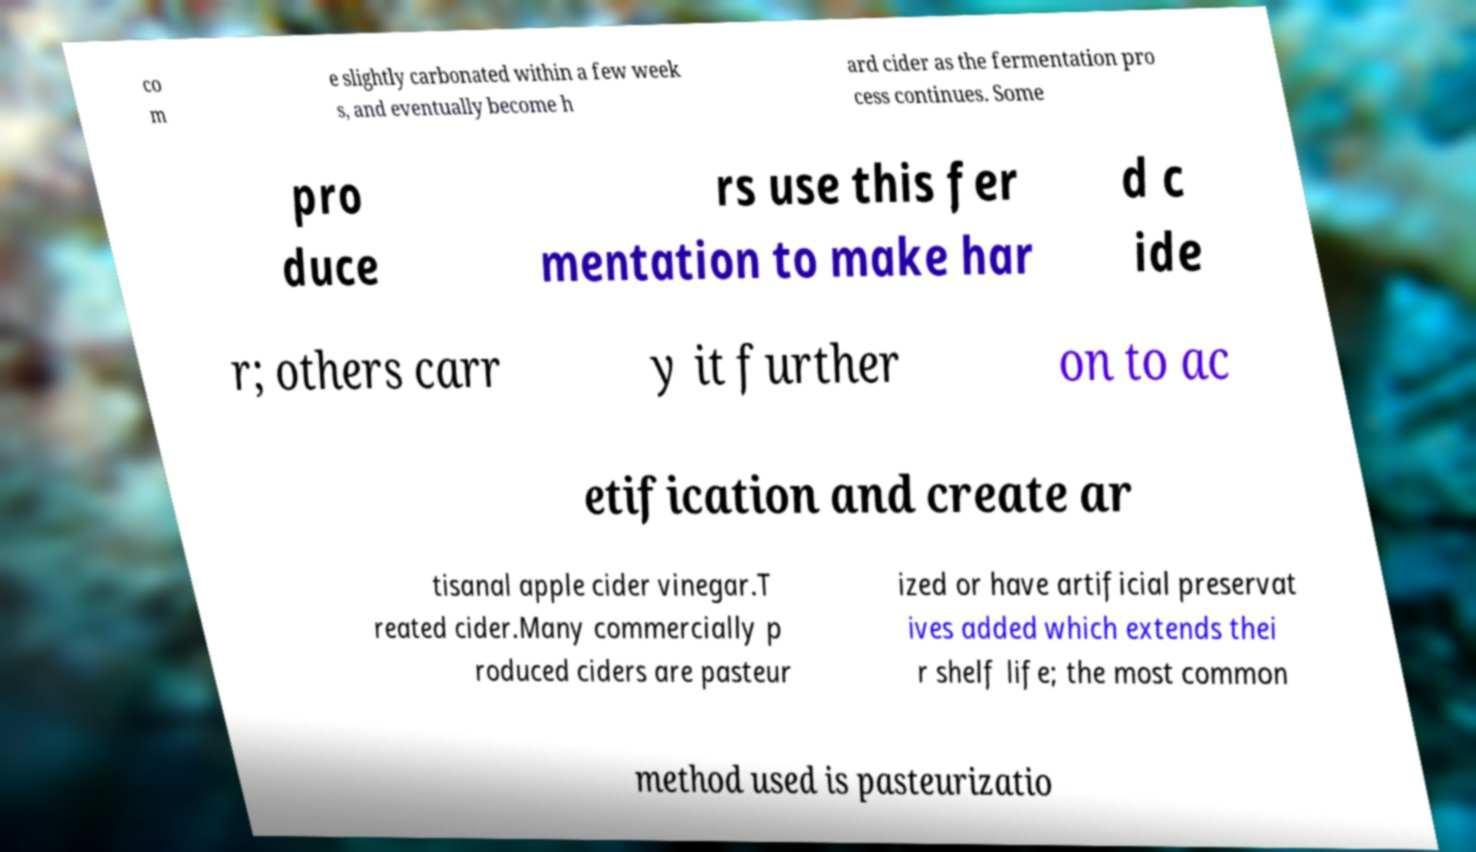Can you accurately transcribe the text from the provided image for me? co m e slightly carbonated within a few week s, and eventually become h ard cider as the fermentation pro cess continues. Some pro duce rs use this fer mentation to make har d c ide r; others carr y it further on to ac etification and create ar tisanal apple cider vinegar.T reated cider.Many commercially p roduced ciders are pasteur ized or have artificial preservat ives added which extends thei r shelf life; the most common method used is pasteurizatio 